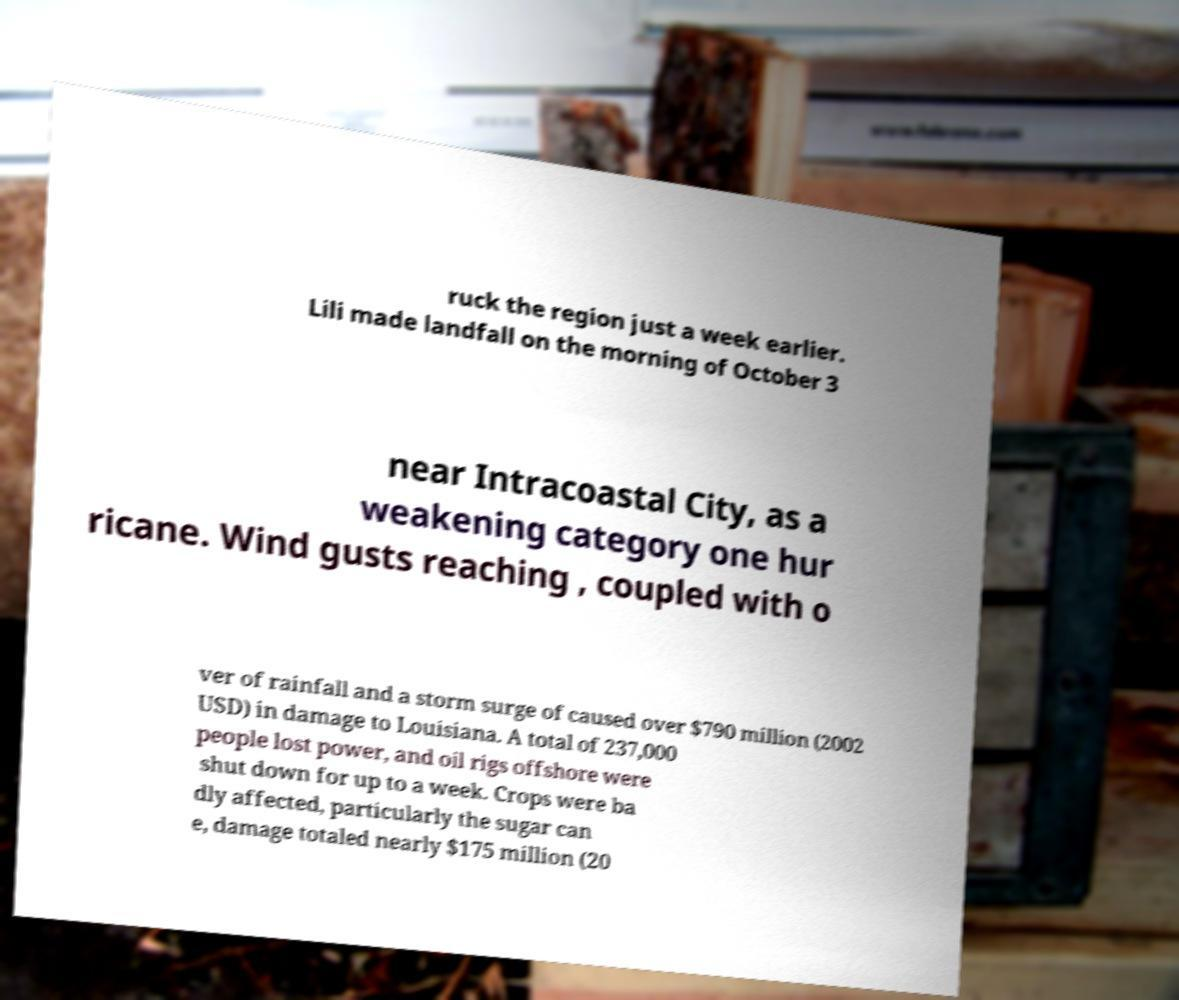Could you assist in decoding the text presented in this image and type it out clearly? ruck the region just a week earlier. Lili made landfall on the morning of October 3 near Intracoastal City, as a weakening category one hur ricane. Wind gusts reaching , coupled with o ver of rainfall and a storm surge of caused over $790 million (2002 USD) in damage to Louisiana. A total of 237,000 people lost power, and oil rigs offshore were shut down for up to a week. Crops were ba dly affected, particularly the sugar can e, damage totaled nearly $175 million (20 